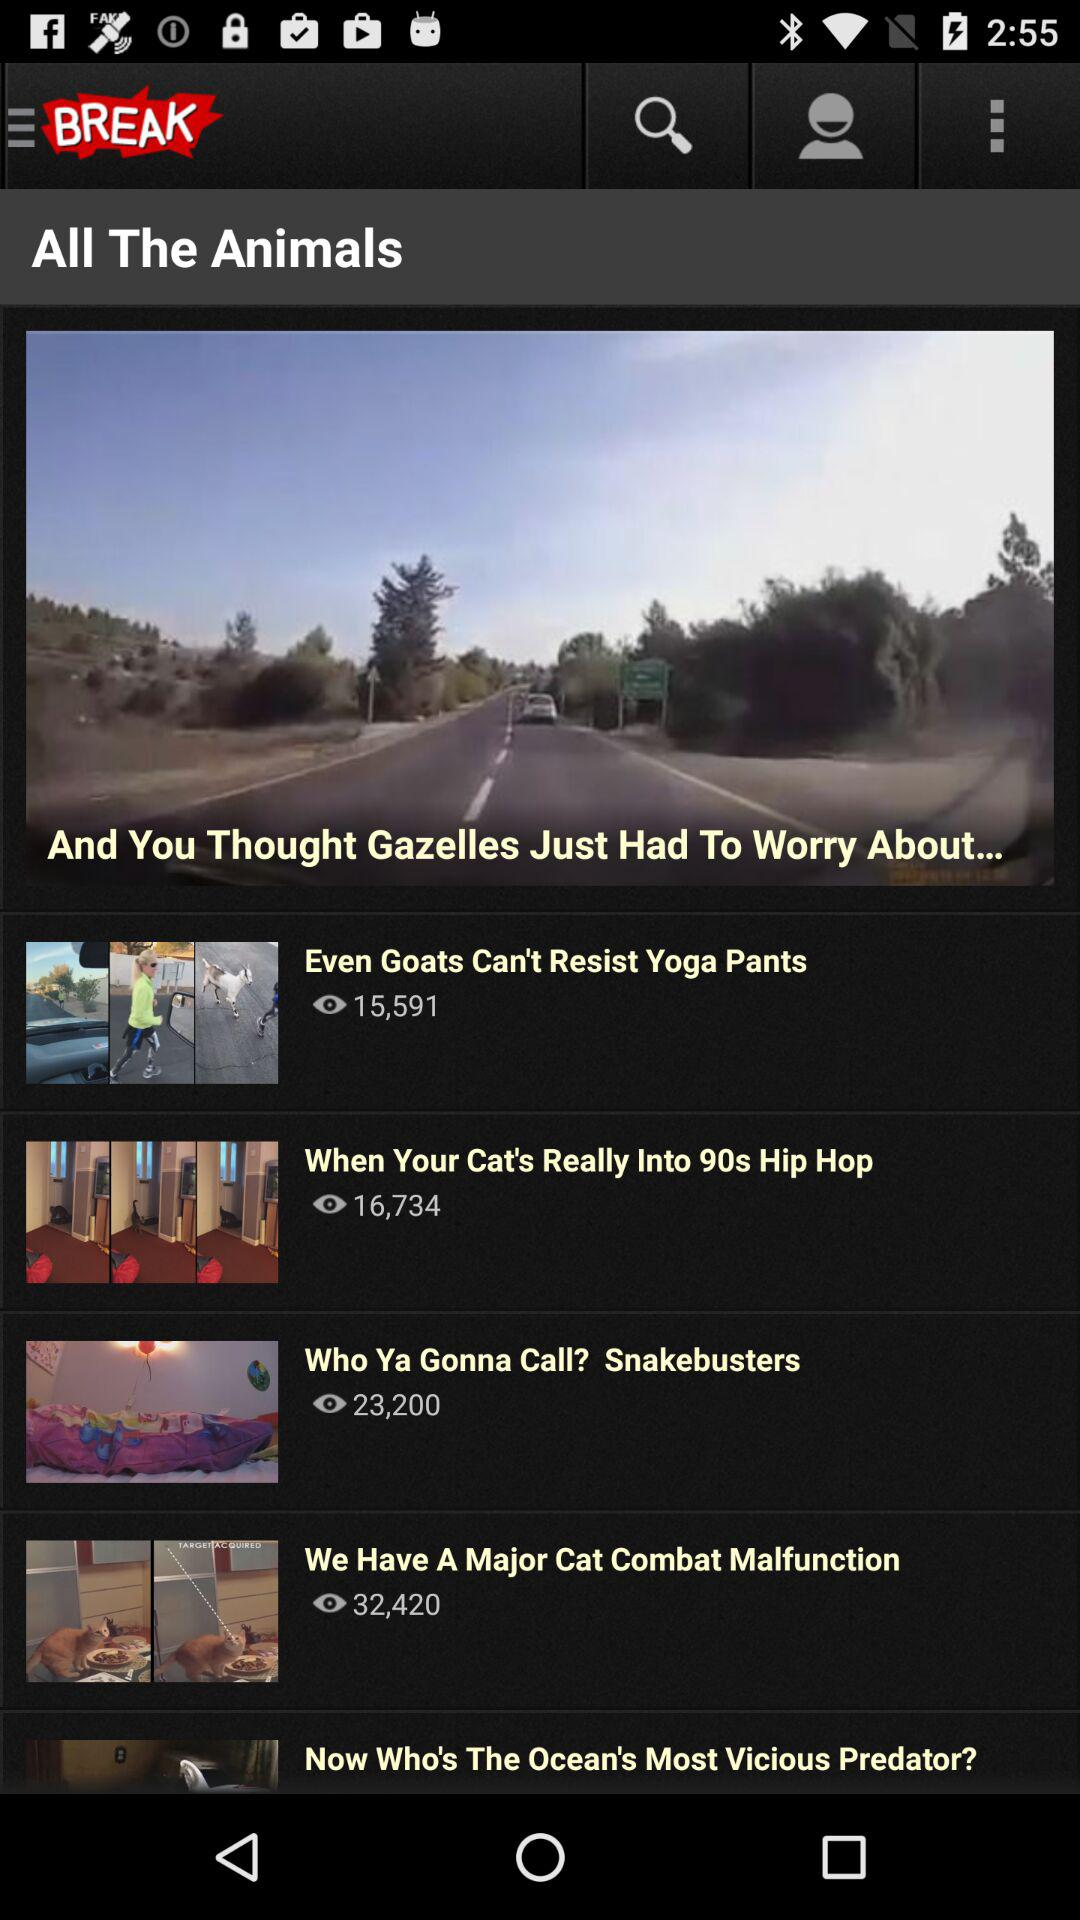How many more people have viewed the video titled 'We Have A Major Cat Combat Malfunction' than 'Even Goats Can't Resist Yoga Pants'?
Answer the question using a single word or phrase. 16829 